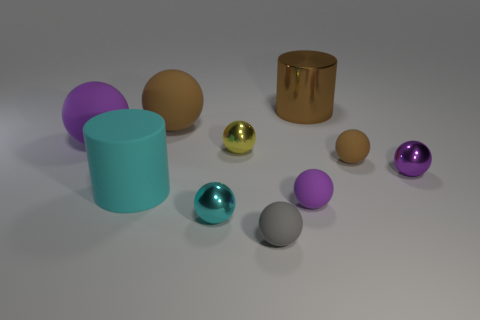Subtract all purple spheres. How many were subtracted if there are1purple spheres left? 2 Subtract all cyan cylinders. How many purple balls are left? 3 Subtract all yellow spheres. How many spheres are left? 7 Subtract all small metallic balls. How many balls are left? 5 Subtract all red spheres. Subtract all yellow cylinders. How many spheres are left? 8 Subtract all cylinders. How many objects are left? 8 Subtract 1 cyan cylinders. How many objects are left? 9 Subtract all big brown shiny cylinders. Subtract all large gray metallic balls. How many objects are left? 9 Add 9 large brown shiny cylinders. How many large brown shiny cylinders are left? 10 Add 2 red shiny balls. How many red shiny balls exist? 2 